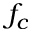Convert formula to latex. <formula><loc_0><loc_0><loc_500><loc_500>f _ { c }</formula> 